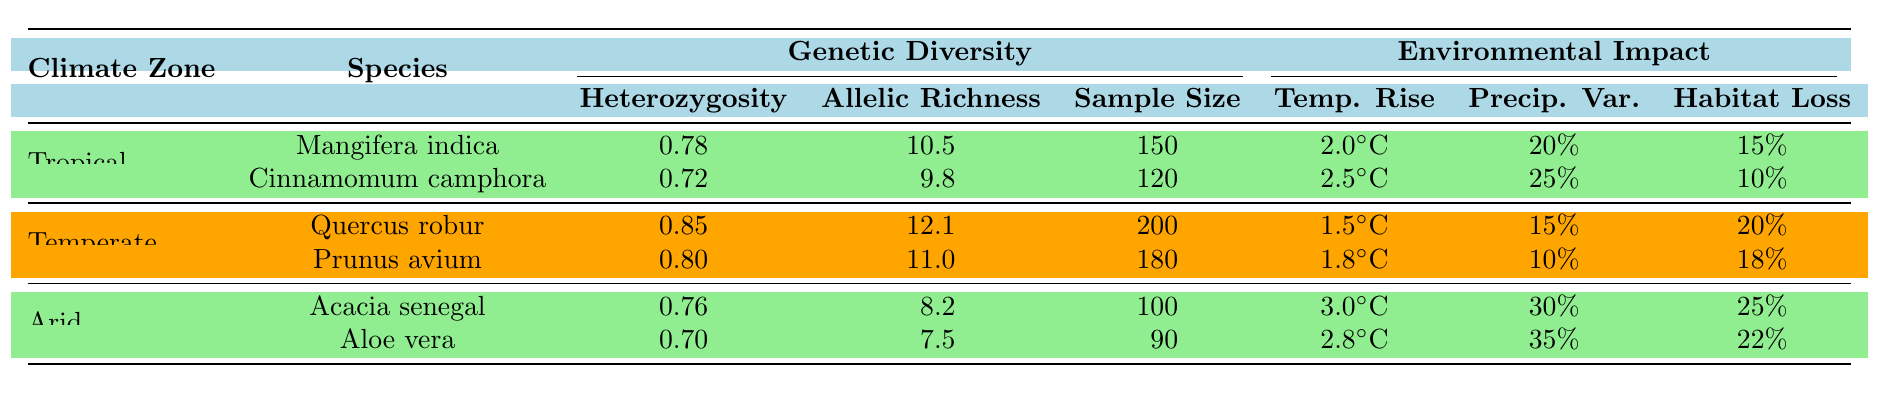What is the heterozygosity of Acacia senegal? The table shows "Acacia senegal" under the Arid climate zone, with a listed heterozygosity of 0.76 in the Genetic Diversity section.
Answer: 0.76 Which species has the highest allelic richness? Looking at the Genetic Diversity section, "Quercus robur" has the highest allelic richness of 12.1 among all species listed in the table.
Answer: Quercus robur What is the average population sample size across all species listed in the table? The population sample sizes are 150 (Mangifera indica), 120 (Cinnamomum camphora), 200 (Quercus robur), 180 (Prunus avium), 100 (Acacia senegal), and 90 (Aloe vera). The total is 150 + 120 + 200 + 180 + 100 + 90 = 940. There are 6 species, so the average is 940/6 ≈ 156.67.
Answer: Approximately 156.67 Is the temperature rise for Aloe vera greater than that for Quercus robur? The temperature rise for Aloe vera is 2.8°C, while for Quercus robur it is 1.5°C. Since 2.8°C is greater than 1.5°C, the statement is true.
Answer: Yes Which climatic zone has the lowest habitat loss among the species listed? In the Environmental Impact section, the habitat loss values for Tropical are 15% (Mangifera indica) and 10% (Cinnamomum camphora), for Temperate are 20% (Quercus robur) and 18% (Prunus avium), and for Arid are 25% (Acacia senegal) and 22% (Aloe vera). The lowest value is 10% from Cinnamomum camphora in the Tropical zone.
Answer: Tropical zone (Cinnamomum camphora) What is the total precipitation variability for the species in the Arid climate zone? The species in the Arid zone are Acacia senegal (30%) and Aloe vera (35%). Adding these gives total precipitation variability of 30% + 35% = 65%.
Answer: 65% Which species shows the greatest percentage of habitat loss? The habitat loss for each species is 15% (Mangifera indica), 10% (Cinnamomum camphora), 20% (Quercus robur), 18% (Prunus avium), 25% (Acacia senegal), and 22% (Aloe vera). Acacia senegal shows the greatest habitat loss at 25%.
Answer: Acacia senegal What is the difference in allelic richness between Quercus robur and Aloe vera? Quercus robur has an allelic richness of 12.1, and Aloe vera has 7.5. The difference is 12.1 - 7.5 = 4.6.
Answer: 4.6 Do any of the species listed have a heterozygosity greater than 0.80? Referring to the heterozygosity values, Quercus robur (0.85) and Prunus avium (0.80) have values at or above 0.80. Therefore, yes, there are species that meet this criterion.
Answer: Yes Calculate the average temperature rise for all species documented in the table. The temperature rises are 2.0°C, 2.5°C, 1.5°C, 1.8°C, 3.0°C, and 2.8°C. Adding these gives a total of 2.0 + 2.5 + 1.5 + 1.8 + 3.0 + 2.8 = 13.6°C. The average is 13.6/6 ≈ 2.27°C.
Answer: Approximately 2.27°C 